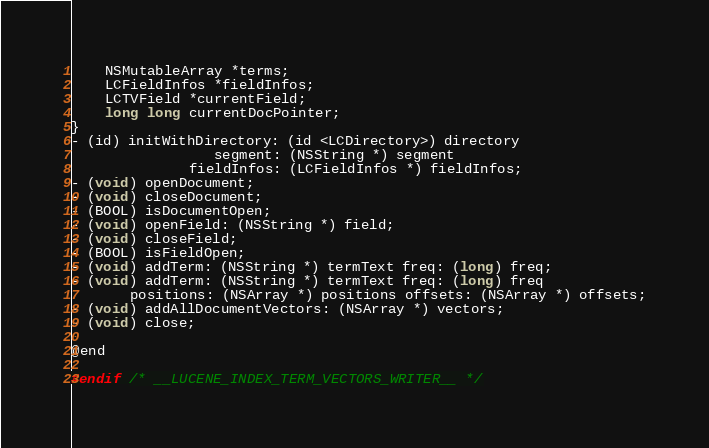Convert code to text. <code><loc_0><loc_0><loc_500><loc_500><_C_>	NSMutableArray *terms;
	LCFieldInfos *fieldInfos;
	LCTVField *currentField;
	long long currentDocPointer;
}
- (id) initWithDirectory: (id <LCDirectory>) directory
				 segment: (NSString *) segment
			  fieldInfos: (LCFieldInfos *) fieldInfos;
- (void) openDocument;
- (void) closeDocument;
- (BOOL) isDocumentOpen;
- (void) openField: (NSString *) field;
- (void) closeField;
- (BOOL) isFieldOpen;
- (void) addTerm: (NSString *) termText freq: (long) freq;
- (void) addTerm: (NSString *) termText freq: (long) freq
	   positions: (NSArray *) positions offsets: (NSArray *) offsets;
- (void) addAllDocumentVectors: (NSArray *) vectors;
- (void) close;

@end

#endif /* __LUCENE_INDEX_TERM_VECTORS_WRITER__ */
</code> 